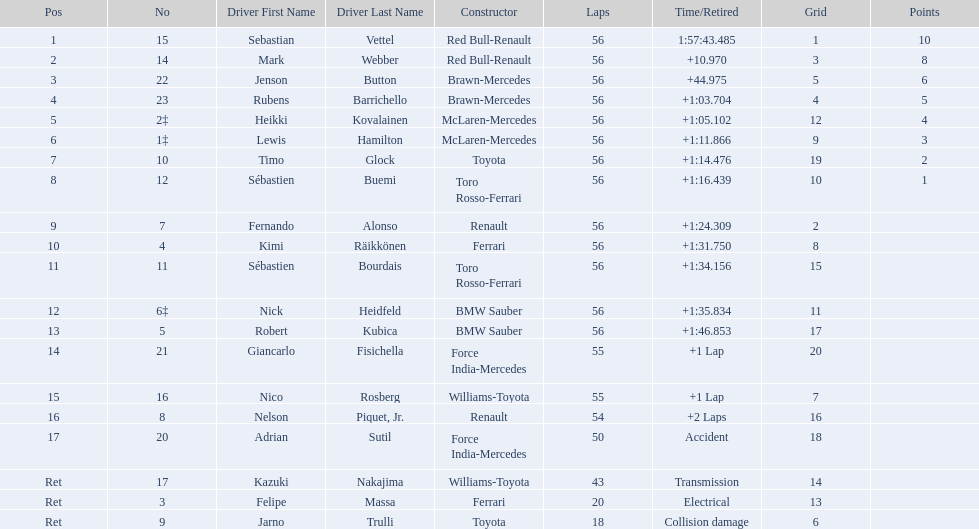Who are all the drivers? Sebastian Vettel, Mark Webber, Jenson Button, Rubens Barrichello, Heikki Kovalainen, Lewis Hamilton, Timo Glock, Sébastien Buemi, Fernando Alonso, Kimi Räikkönen, Sébastien Bourdais, Nick Heidfeld, Robert Kubica, Giancarlo Fisichella, Nico Rosberg, Nelson Piquet, Jr., Adrian Sutil, Kazuki Nakajima, Felipe Massa, Jarno Trulli. What were their finishing times? 1:57:43.485, +10.970, +44.975, +1:03.704, +1:05.102, +1:11.866, +1:14.476, +1:16.439, +1:24.309, +1:31.750, +1:34.156, +1:35.834, +1:46.853, +1 Lap, +1 Lap, +2 Laps, Accident, Transmission, Electrical, Collision damage. Who finished last? Robert Kubica. 